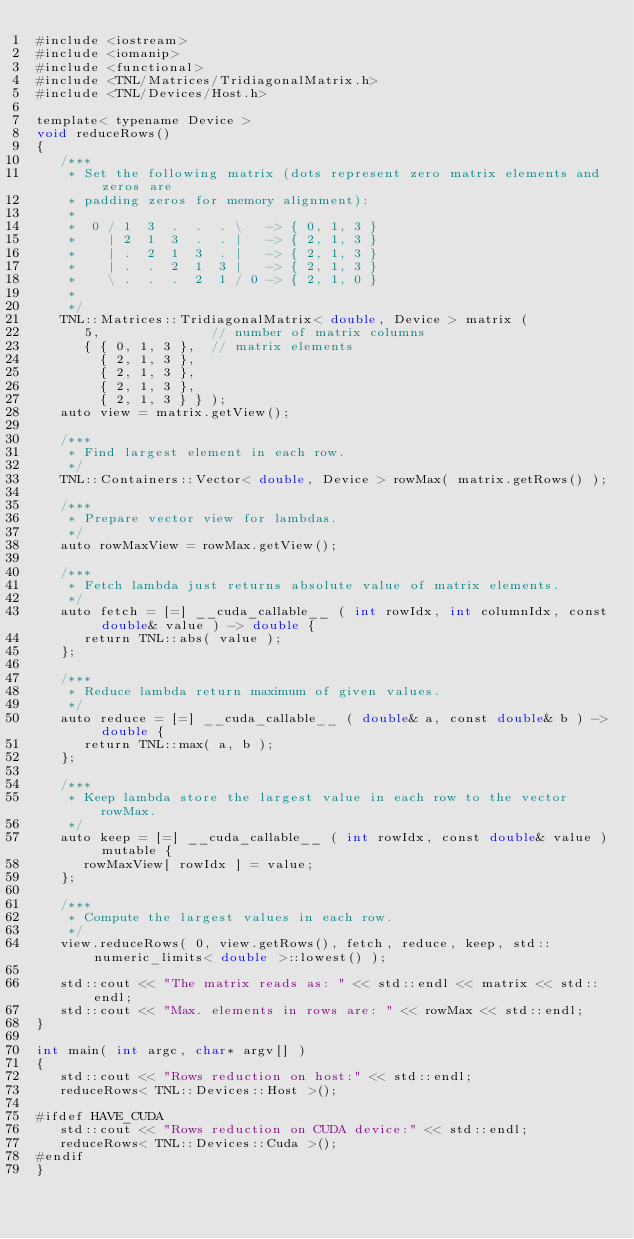Convert code to text. <code><loc_0><loc_0><loc_500><loc_500><_Cuda_>#include <iostream>
#include <iomanip>
#include <functional>
#include <TNL/Matrices/TridiagonalMatrix.h>
#include <TNL/Devices/Host.h>

template< typename Device >
void reduceRows()
{
   /***
    * Set the following matrix (dots represent zero matrix elements and zeros are
    * padding zeros for memory alignment):
    *
    *  0 / 1  3  .  .  . \   -> { 0, 1, 3 }
    *    | 2  1  3  .  . |   -> { 2, 1, 3 }
    *    | .  2  1  3  . |   -> { 2, 1, 3 }
    *    | .  .  2  1  3 |   -> { 2, 1, 3 }
    *    \ .  .  .  2  1 / 0 -> { 2, 1, 0 }
    *
    */
   TNL::Matrices::TridiagonalMatrix< double, Device > matrix (
      5,              // number of matrix columns
      { { 0, 1, 3 },  // matrix elements
        { 2, 1, 3 },
        { 2, 1, 3 },
        { 2, 1, 3 },
        { 2, 1, 3 } } );
   auto view = matrix.getView();

   /***
    * Find largest element in each row.
    */
   TNL::Containers::Vector< double, Device > rowMax( matrix.getRows() );

   /***
    * Prepare vector view for lambdas.
    */
   auto rowMaxView = rowMax.getView();

   /***
    * Fetch lambda just returns absolute value of matrix elements.
    */
   auto fetch = [=] __cuda_callable__ ( int rowIdx, int columnIdx, const double& value ) -> double {
      return TNL::abs( value );
   };

   /***
    * Reduce lambda return maximum of given values.
    */
   auto reduce = [=] __cuda_callable__ ( double& a, const double& b ) -> double {
      return TNL::max( a, b );
   };

   /***
    * Keep lambda store the largest value in each row to the vector rowMax.
    */
   auto keep = [=] __cuda_callable__ ( int rowIdx, const double& value ) mutable {
      rowMaxView[ rowIdx ] = value;
   };

   /***
    * Compute the largest values in each row.
    */
   view.reduceRows( 0, view.getRows(), fetch, reduce, keep, std::numeric_limits< double >::lowest() );

   std::cout << "The matrix reads as: " << std::endl << matrix << std::endl;
   std::cout << "Max. elements in rows are: " << rowMax << std::endl;
}

int main( int argc, char* argv[] )
{
   std::cout << "Rows reduction on host:" << std::endl;
   reduceRows< TNL::Devices::Host >();

#ifdef HAVE_CUDA
   std::cout << "Rows reduction on CUDA device:" << std::endl;
   reduceRows< TNL::Devices::Cuda >();
#endif
}
</code> 